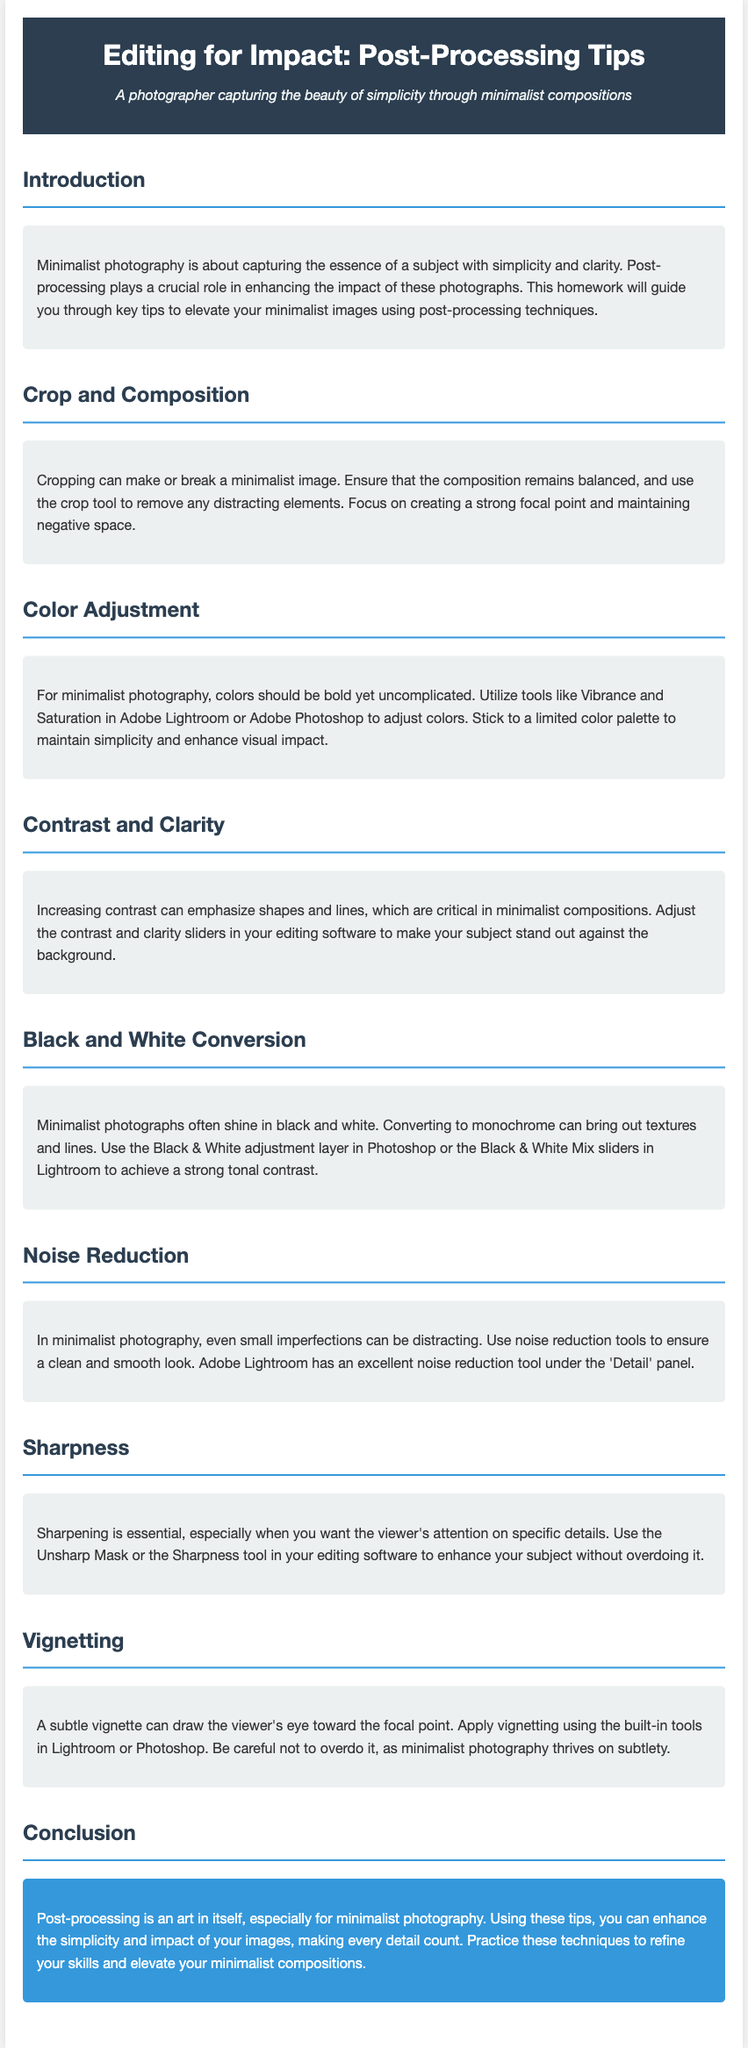What is the title of the document? The title is stated prominently at the top of the document.
Answer: Editing for Impact: Post-Processing Tips What is the main focus of minimalist photography? The document describes the essence of minimalist photography in the introduction section.
Answer: Simplicity and clarity Which tool is suggested for adjusting colors in photographs? The color adjustment section mentions specific software tools for this purpose.
Answer: Adobe Lightroom or Adobe Photoshop What is emphasized in the section on contrast and clarity? The document highlights the effect of these adjustments on minimalist compositions.
Answer: Shapes and lines What effect does black and white conversion have on minimalist photographs? The section discusses the advantages of converting to monochrome.
Answer: Brings out textures and lines Which parameter should be adjusted to reduce noise in photographs? The noise reduction section advises on specific tools to use for this adjustment.
Answer: Detail panel What should be the approach to applying vignetting in minimalist photography? The document advises on how to use vignetting subtly.
Answer: Apply subtly What is the main purpose of sharpening in post-processing? The sharpness section outlines the goal of this editing technique.
Answer: Enhance specific details What does the conclusion suggest about post-processing for minimalist photography? The conclusion summarizes the overall importance of the editing process.
Answer: It is an art in itself 